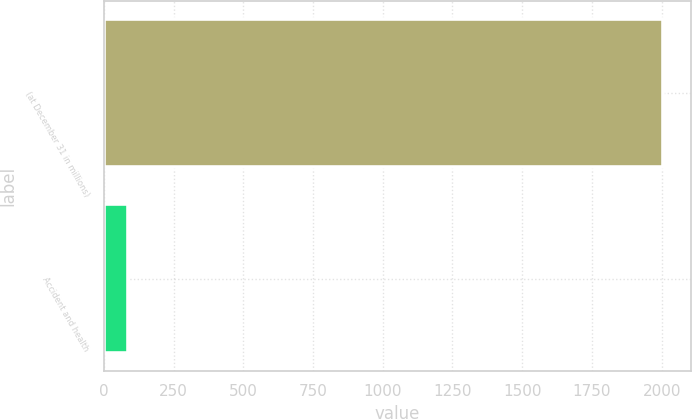Convert chart to OTSL. <chart><loc_0><loc_0><loc_500><loc_500><bar_chart><fcel>(at December 31 in millions)<fcel>Accident and health<nl><fcel>2004<fcel>86<nl></chart> 